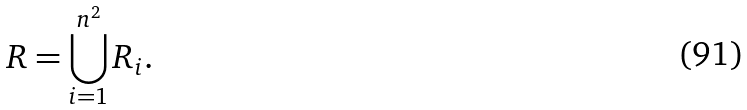<formula> <loc_0><loc_0><loc_500><loc_500>R = \bigcup _ { i = 1 } ^ { n ^ { 2 } } R _ { i } .</formula> 